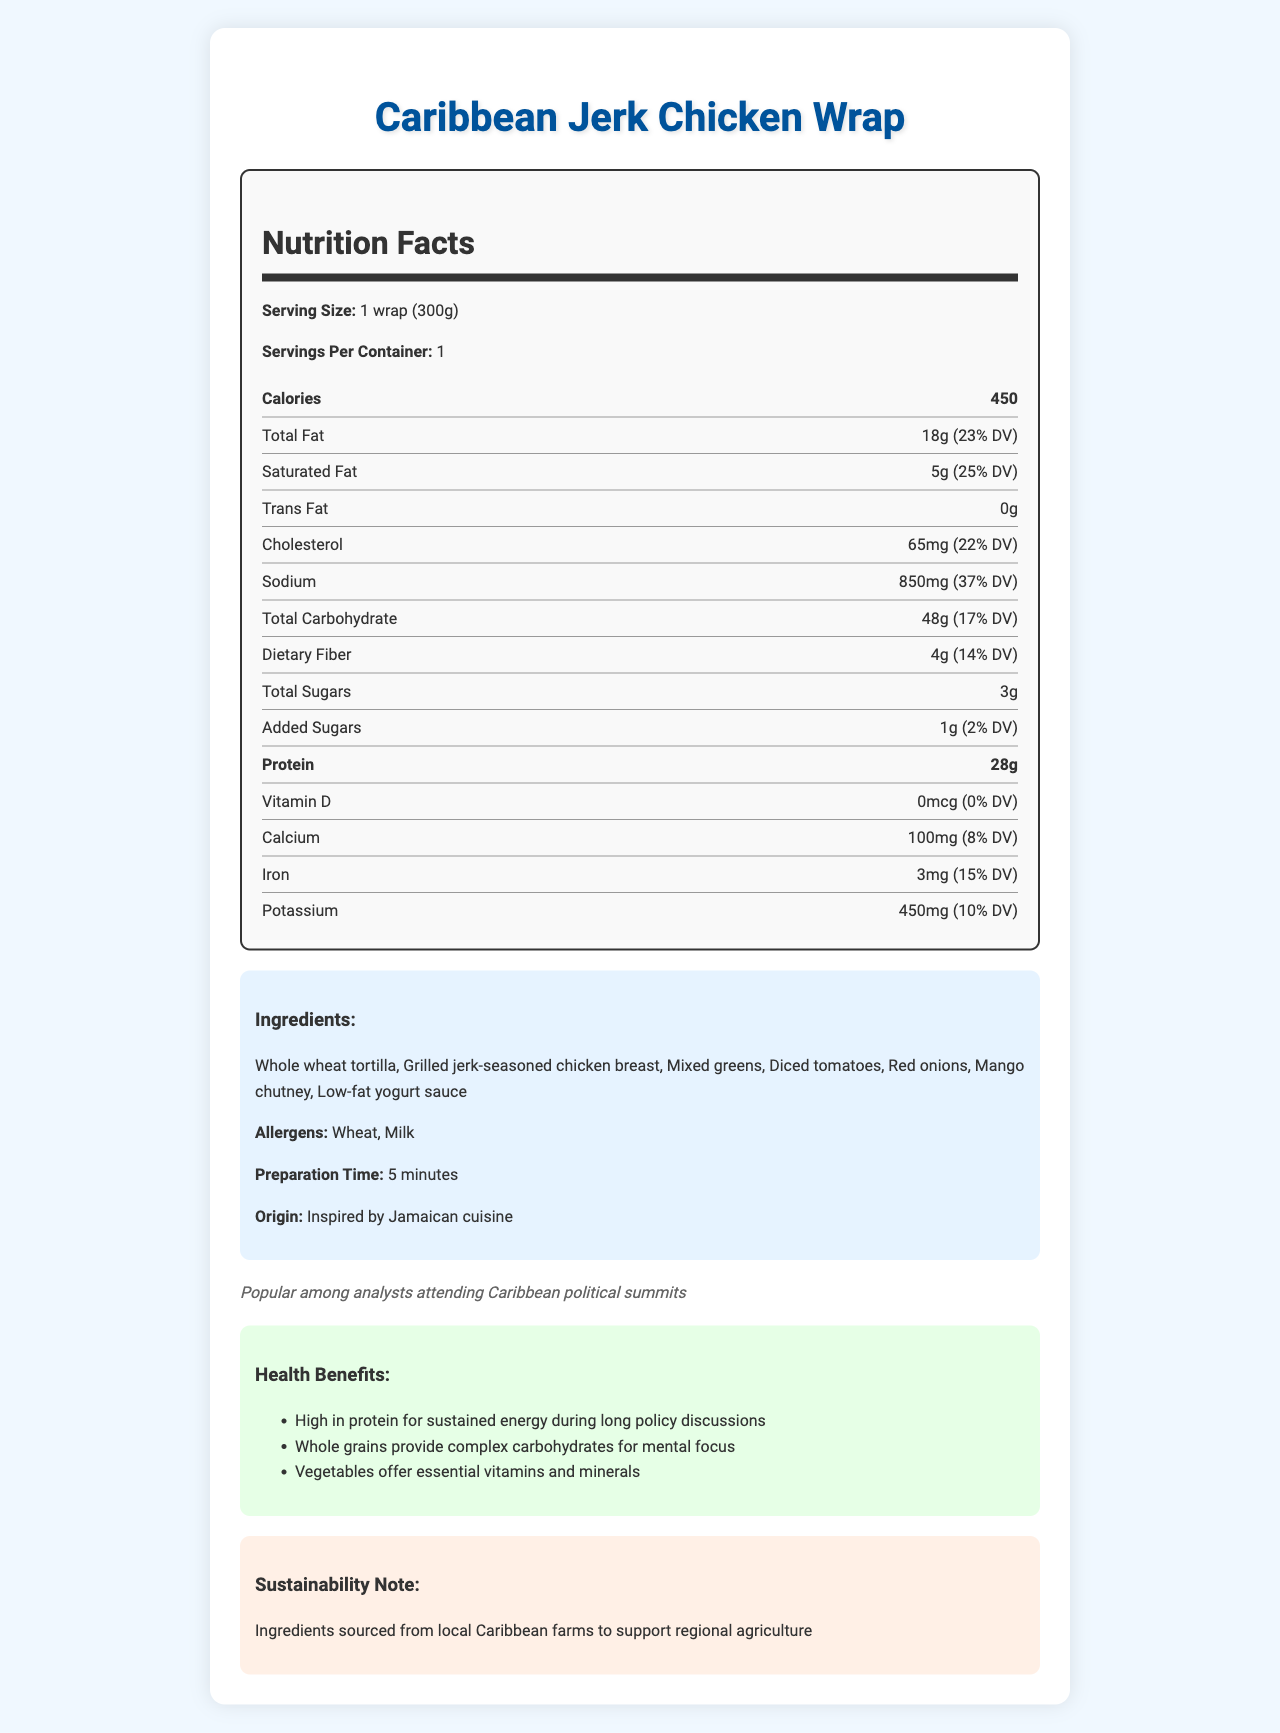What is the serving size of the Caribbean Jerk Chicken Wrap? The serving size is stated as 1 wrap (300g) in the nutrition label section of the document.
Answer: 1 wrap (300g) How many calories does one serving of the Caribbean Jerk Chicken Wrap contain? The document specifies that each serving contains 450 calories.
Answer: 450 What percentage of the daily value for sodium does one serving provide? According to the document, one serving provides 850mg of sodium, which is 37% of the daily value.
Answer: 37% What is the total amount of dietary fiber in one wrap? The document notes that each wrap contains 4g of dietary fiber, which is 14% of the daily value.
Answer: 4g What allergens are present in the Caribbean Jerk Chicken Wrap? The document lists wheat and milk as allergens in the ingredients section.
Answer: Wheat, Milk What is the leading health benefit of the wrap for busy political analysts? A. High protein B. Low fat C. High sugar D. High sodium The document highlights that the wrap is high in protein, which provides sustained energy during long policy discussions, making it particularly beneficial for busy political analysts.
Answer: A. High protein How much cholesterol is in one serving of the Caribbean Jerk Chicken Wrap? A. 20mg B. 50mg C. 65mg D. 100mg The nutrition facts indicate that one serving contains 65mg of cholesterol, which is 22% of the daily value.
Answer: C. 65mg Is the Caribbean Jerk Chicken Wrap a good source of Vitamin D? The document states that the wrap contains 0mcg of Vitamin D, which is 0% of the daily value.
Answer: No Summarize the key information about the Caribbean Jerk Chicken Wrap as presented in the document. This summary captures the primary details regarding the nutritional content, ingredients, health benefits, preparation time, and contextual relevance of the Caribbean Jerk Chicken Wrap.
Answer: The Caribbean Jerk Chicken Wrap is a quick meal with 450 calories per serving, providing high protein (28g) and moderate amounts of carbohydrates (48g). It includes whole wheat tortilla, grilled jerk-seasoned chicken, mixed greens, and other vegetables with mango chutney and low-fat yogurt sauce. It is popular among political analysts attending Caribbean summits due to its healthy composition and quick preparation time of 5 minutes. The wrap supports sustained energy and mental focus, with ingredients sourced from local Caribbean farms for sustainability. What is the origin of the Caribbean Jerk Chicken Wrap? The origin is mentioned as inspired by Jamaican cuisine in the document.
Answer: Inspired by Jamaican cuisine What is the total amount of sugars (including added sugars) in one serving of the Caribbean Jerk Chicken Wrap? The document indicates that the total sugars amount to 3g, and added sugars are 1g, making the total sugar content in one serving 4g.
Answer: 4g Does one serving of the wrap provide more calcium or potassium? The document states that one serving includes 100mg of calcium (8% DV) and 450mg of potassium (10% DV), indicating that it provides more potassium.
Answer: Potassium Is this wrap particularly low in any important nutrient? The wrap contains 0mcg of Vitamin D, which is 0% of the daily value, making it particularly low in this nutrient.
Answer: Vitamin D Can it be determined whether the Caribbean Jerk Chicken Wrap is gluten-free? The document mentions wheat as an allergen, indicating the presence of gluten, making the wrap not gluten-free; hence it can be determined.
Answer: No What is the sustainability note mentioned in the document? The sustainability note mentions that the ingredients are sourced from local Caribbean farms to support regional agriculture.
Answer: Ingredients sourced from local Caribbean farms to support regional agriculture 